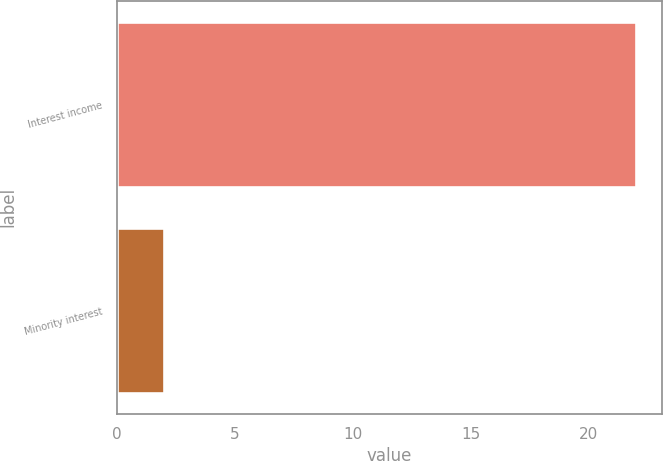Convert chart. <chart><loc_0><loc_0><loc_500><loc_500><bar_chart><fcel>Interest income<fcel>Minority interest<nl><fcel>22<fcel>2<nl></chart> 